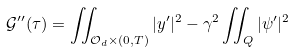Convert formula to latex. <formula><loc_0><loc_0><loc_500><loc_500>\mathcal { G } ^ { \prime \prime } ( \tau ) = \iint _ { \mathcal { O } _ { d } \times ( 0 , T ) } | y ^ { \prime } | ^ { 2 } - \gamma ^ { 2 } \iint _ { Q } | \psi ^ { \prime } | ^ { 2 }</formula> 